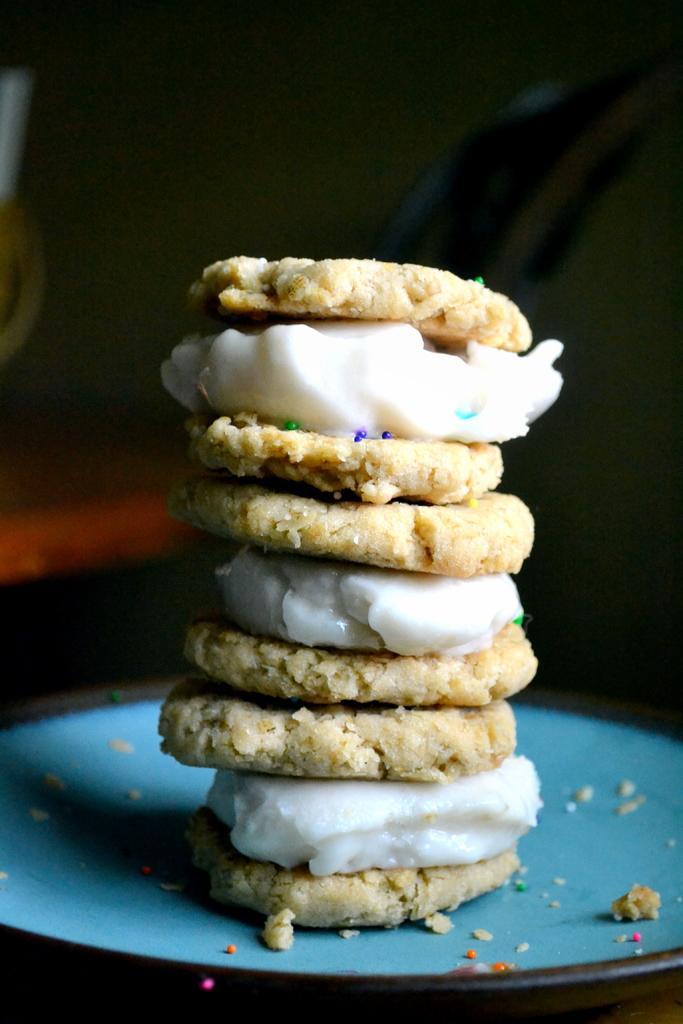Describe this image in one or two sentences. Here we can see food and a plate. There is a dark background. 